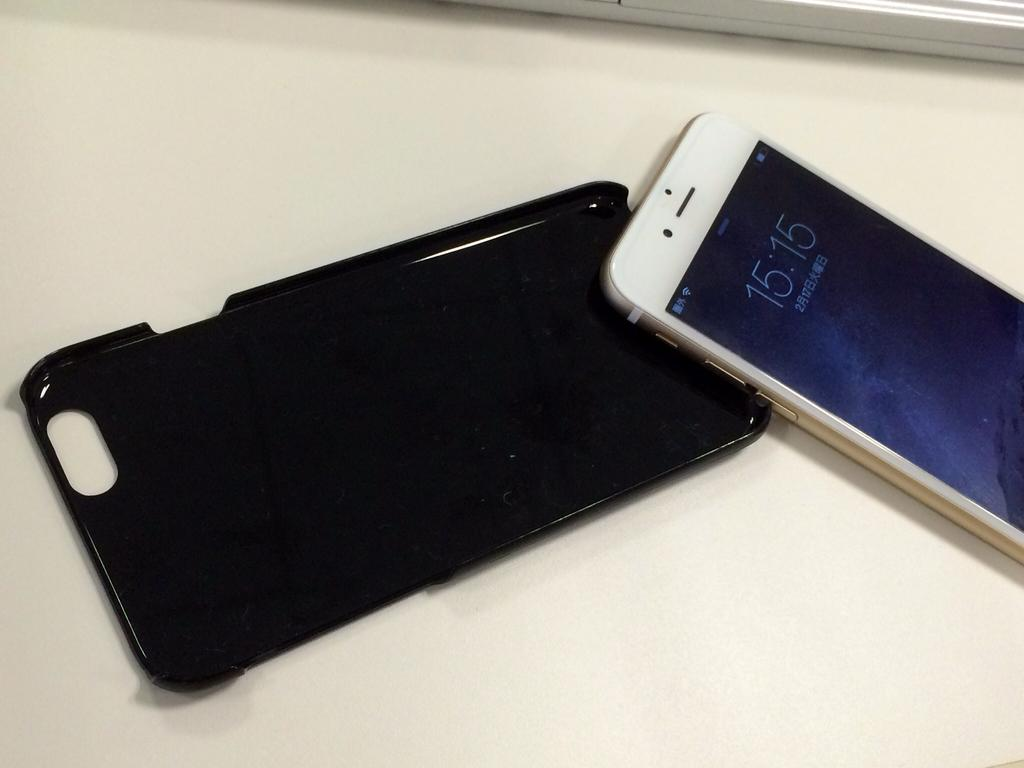<image>
Render a clear and concise summary of the photo. A white iPhone that is detached from its cover shows that the time is 15:15. 